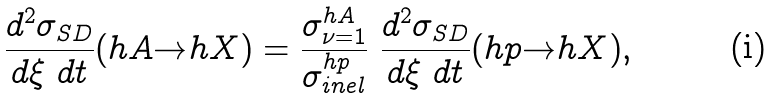Convert formula to latex. <formula><loc_0><loc_0><loc_500><loc_500>\frac { d ^ { 2 } \sigma _ { S D } } { d \xi \ d t } ( h A { \rightarrow } h X ) = \frac { \sigma ^ { h A } _ { \nu = 1 } } { \sigma ^ { h p } _ { i n e l } } \ \frac { d ^ { 2 } \sigma _ { S D } } { d \xi \ d t } ( h p { \rightarrow } h X ) ,</formula> 